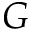<formula> <loc_0><loc_0><loc_500><loc_500>G</formula> 